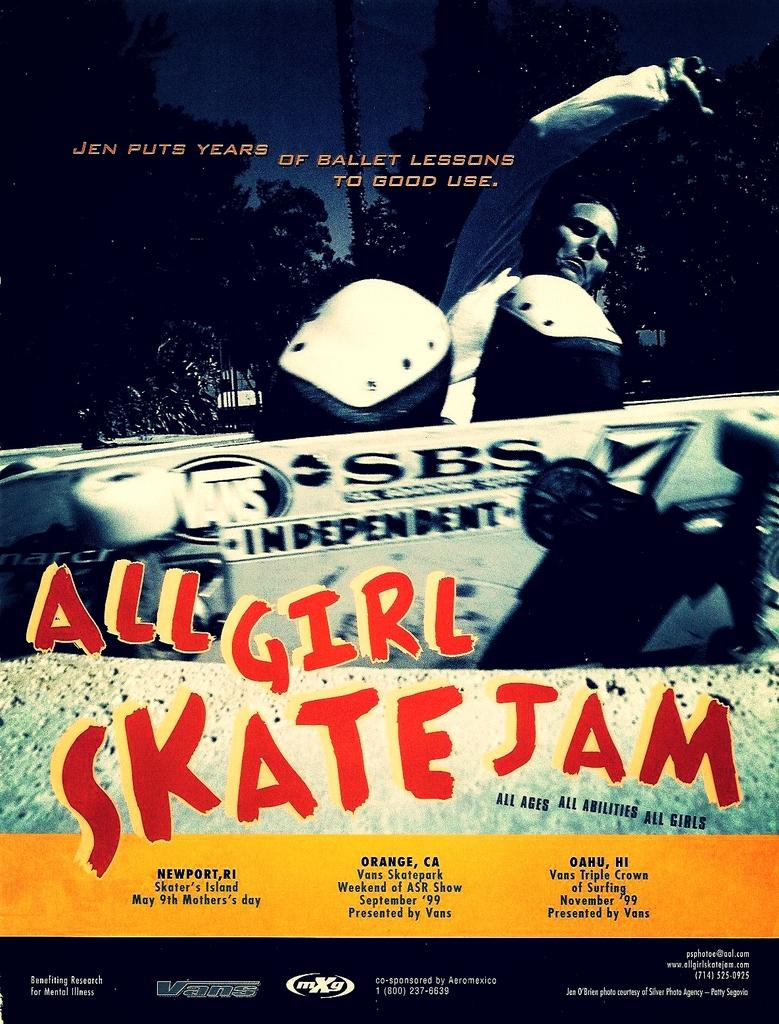<image>
Offer a succinct explanation of the picture presented. A poster for All Girl Skate Jam where Jen is showing how she puts ballet lessons to work. 